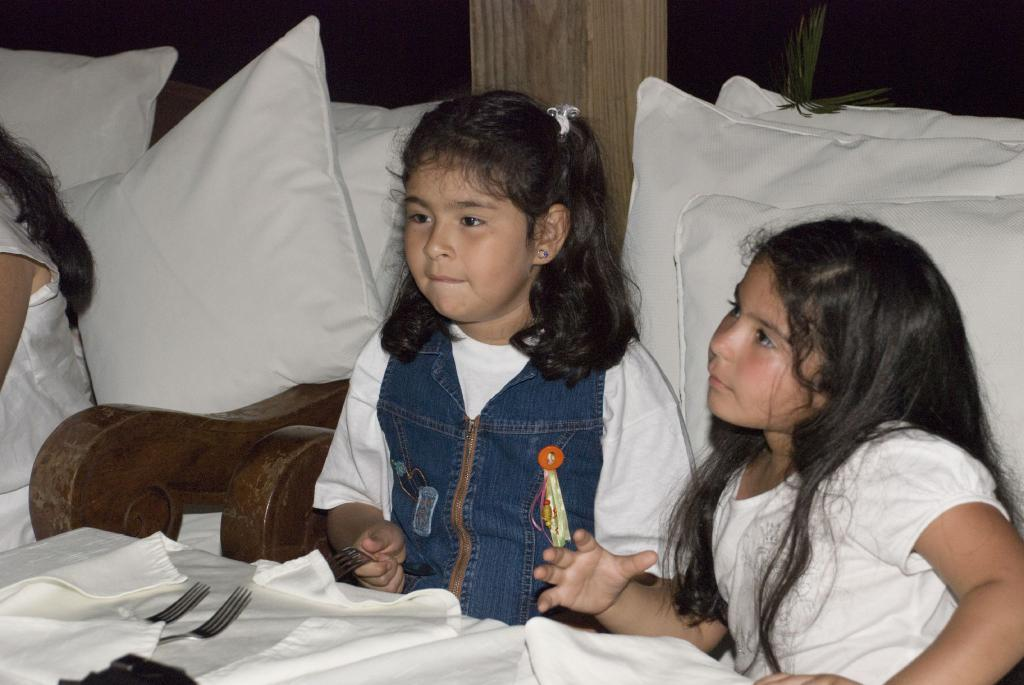Who is present in the image? There are girls in the image. What are the girls doing in the image? The girls are sitting on sofas. What can be seen in the background of the image? There are windows and a wall in the background of the image. What items are on the table in the image? There are forks and napkins on the table in the image. How many geese are flying by the window in the image? There are no geese present in the image; only the girls, sofas, windows, wall, forks, and napkins can be seen. 